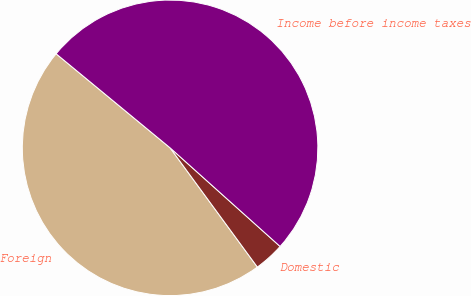Convert chart to OTSL. <chart><loc_0><loc_0><loc_500><loc_500><pie_chart><fcel>Foreign<fcel>Domestic<fcel>Income before income taxes<nl><fcel>46.04%<fcel>3.31%<fcel>50.65%<nl></chart> 